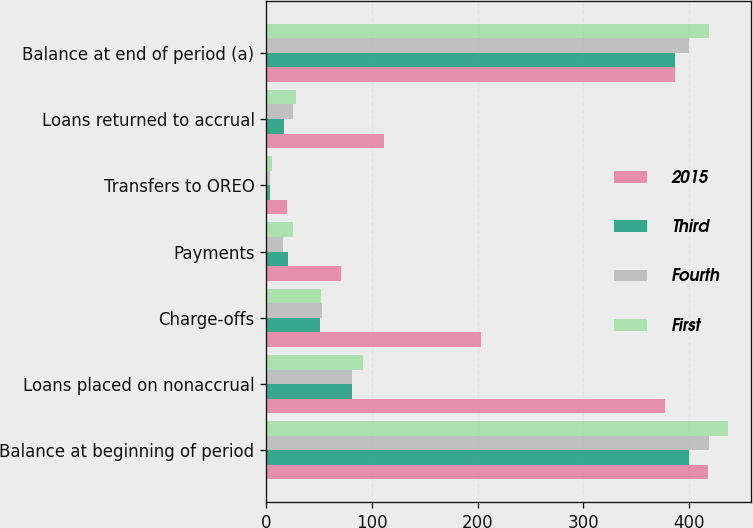<chart> <loc_0><loc_0><loc_500><loc_500><stacked_bar_chart><ecel><fcel>Balance at beginning of period<fcel>Loans placed on nonaccrual<fcel>Charge-offs<fcel>Payments<fcel>Transfers to OREO<fcel>Loans returned to accrual<fcel>Balance at end of period (a)<nl><fcel>2015<fcel>418<fcel>377<fcel>203<fcel>71<fcel>20<fcel>111<fcel>387<nl><fcel>Third<fcel>400<fcel>81<fcel>51<fcel>21<fcel>4<fcel>17<fcel>387<nl><fcel>Fourth<fcel>419<fcel>81<fcel>53<fcel>16<fcel>4<fcel>25<fcel>400<nl><fcel>First<fcel>437<fcel>92<fcel>52<fcel>25<fcel>5<fcel>28<fcel>419<nl></chart> 